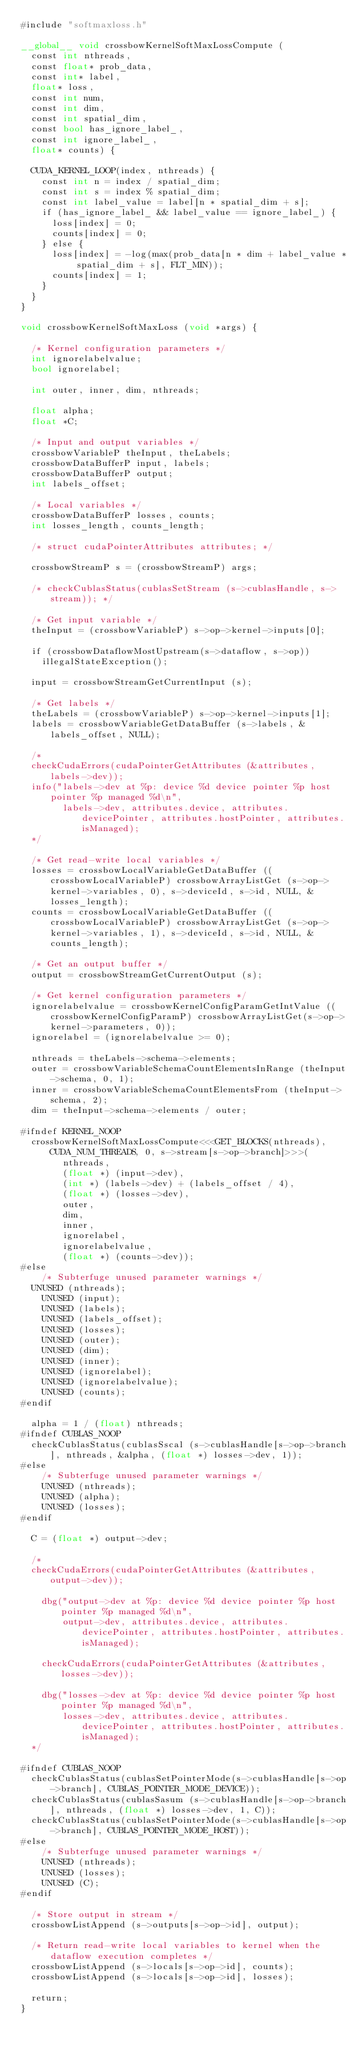Convert code to text. <code><loc_0><loc_0><loc_500><loc_500><_Cuda_>#include "softmaxloss.h"

__global__ void crossbowKernelSoftMaxLossCompute (
	const int nthreads,
	const float* prob_data,
	const int* label,
	float* loss,
	const int num,
	const int dim,
	const int spatial_dim,
	const bool has_ignore_label_,
	const int ignore_label_,
	float* counts) {

	CUDA_KERNEL_LOOP(index, nthreads) {
		const int n = index / spatial_dim;
		const int s = index % spatial_dim;
		const int label_value = label[n * spatial_dim + s];
		if (has_ignore_label_ && label_value == ignore_label_) {
			loss[index] = 0;
			counts[index] = 0;
		} else {
			loss[index] = -log(max(prob_data[n * dim + label_value * spatial_dim + s], FLT_MIN));
			counts[index] = 1;
		}
	}
}

void crossbowKernelSoftMaxLoss (void *args) {

	/* Kernel configuration parameters */
	int ignorelabelvalue;
	bool ignorelabel;

	int outer, inner, dim, nthreads;

	float alpha;
	float *C;

	/* Input and output variables */
	crossbowVariableP theInput, theLabels;
	crossbowDataBufferP input, labels;
	crossbowDataBufferP output;
	int labels_offset;

	/* Local variables */
	crossbowDataBufferP losses, counts;
	int losses_length, counts_length;
	
	/* struct cudaPointerAttributes attributes; */
	
	crossbowStreamP s = (crossbowStreamP) args;

	/* checkCublasStatus(cublasSetStream (s->cublasHandle, s->stream)); */

	/* Get input variable */
	theInput = (crossbowVariableP) s->op->kernel->inputs[0];

	if (crossbowDataflowMostUpstream(s->dataflow, s->op))
		illegalStateException();

	input = crossbowStreamGetCurrentInput (s);

	/* Get labels */
	theLabels = (crossbowVariableP) s->op->kernel->inputs[1];
	labels = crossbowVariableGetDataBuffer (s->labels, &labels_offset, NULL);
	
	/*
	checkCudaErrors(cudaPointerGetAttributes (&attributes, labels->dev));
	info("labels->dev at %p: device %d device pointer %p host pointer %p managed %d\n", 
        labels->dev, attributes.device, attributes.devicePointer, attributes.hostPointer, attributes.isManaged);
	*/
	
	/* Get read-write local variables */
	losses = crossbowLocalVariableGetDataBuffer ((crossbowLocalVariableP) crossbowArrayListGet (s->op->kernel->variables, 0), s->deviceId, s->id, NULL, &losses_length);
	counts = crossbowLocalVariableGetDataBuffer ((crossbowLocalVariableP) crossbowArrayListGet (s->op->kernel->variables, 1), s->deviceId, s->id, NULL, &counts_length);

	/* Get an output buffer */
	output = crossbowStreamGetCurrentOutput (s);

	/* Get kernel configuration parameters */
	ignorelabelvalue = crossbowKernelConfigParamGetIntValue ((crossbowKernelConfigParamP) crossbowArrayListGet(s->op->kernel->parameters, 0));
	ignorelabel = (ignorelabelvalue >= 0);

	nthreads = theLabels->schema->elements;
	outer = crossbowVariableSchemaCountElementsInRange (theInput->schema, 0, 1);
	inner = crossbowVariableSchemaCountElementsFrom (theInput->schema, 2);
	dim = theInput->schema->elements / outer;

#ifndef KERNEL_NOOP
	crossbowKernelSoftMaxLossCompute<<<GET_BLOCKS(nthreads), CUDA_NUM_THREADS, 0, s->stream[s->op->branch]>>>(
        nthreads, 
        (float *) (input->dev), 
        (int *) (labels->dev) + (labels_offset / 4), 
        (float *) (losses->dev), 
        outer, 
        dim, 
        inner, 
        ignorelabel, 
        ignorelabelvalue, 
        (float *) (counts->dev));
#else
    /* Subterfuge unused parameter warnings */
	UNUSED (nthreads);
    UNUSED (input);
    UNUSED (labels);
    UNUSED (labels_offset);
    UNUSED (losses);
    UNUSED (outer);
    UNUSED (dim);
    UNUSED (inner);
    UNUSED (ignorelabel);
    UNUSED (ignorelabelvalue);
    UNUSED (counts);
#endif

	alpha = 1 / (float) nthreads;
#ifndef CUBLAS_NOOP
	checkCublasStatus(cublasSscal (s->cublasHandle[s->op->branch], nthreads, &alpha, (float *) losses->dev, 1));
#else
    /* Subterfuge unused parameter warnings */
    UNUSED (nthreads);
    UNUSED (alpha);
    UNUSED (losses);
#endif
    
	C = (float *) output->dev;
	
	/*
	checkCudaErrors(cudaPointerGetAttributes (&attributes, output->dev));
	
    dbg("output->dev at %p: device %d device pointer %p host pointer %p managed %d\n", 
        output->dev, attributes.device, attributes.devicePointer, attributes.hostPointer, attributes.isManaged);
	
    checkCudaErrors(cudaPointerGetAttributes (&attributes, losses->dev));
	
    dbg("losses->dev at %p: device %d device pointer %p host pointer %p managed %d\n", 
        losses->dev, attributes.device, attributes.devicePointer, attributes.hostPointer, attributes.isManaged);
	*/

#ifndef CUBLAS_NOOP
	checkCublasStatus(cublasSetPointerMode(s->cublasHandle[s->op->branch], CUBLAS_POINTER_MODE_DEVICE));
	checkCublasStatus(cublasSasum (s->cublasHandle[s->op->branch], nthreads, (float *) losses->dev, 1, C));
	checkCublasStatus(cublasSetPointerMode(s->cublasHandle[s->op->branch], CUBLAS_POINTER_MODE_HOST));
#else
    /* Subterfuge unused parameter warnings */
    UNUSED (nthreads);
    UNUSED (losses);
    UNUSED (C);
#endif
    
	/* Store output in stream */
	crossbowListAppend (s->outputs[s->op->id], output);

	/* Return read-write local variables to kernel when the dataflow execution completes */
	crossbowListAppend (s->locals[s->op->id], counts);
	crossbowListAppend (s->locals[s->op->id], losses);

	return;
}
</code> 